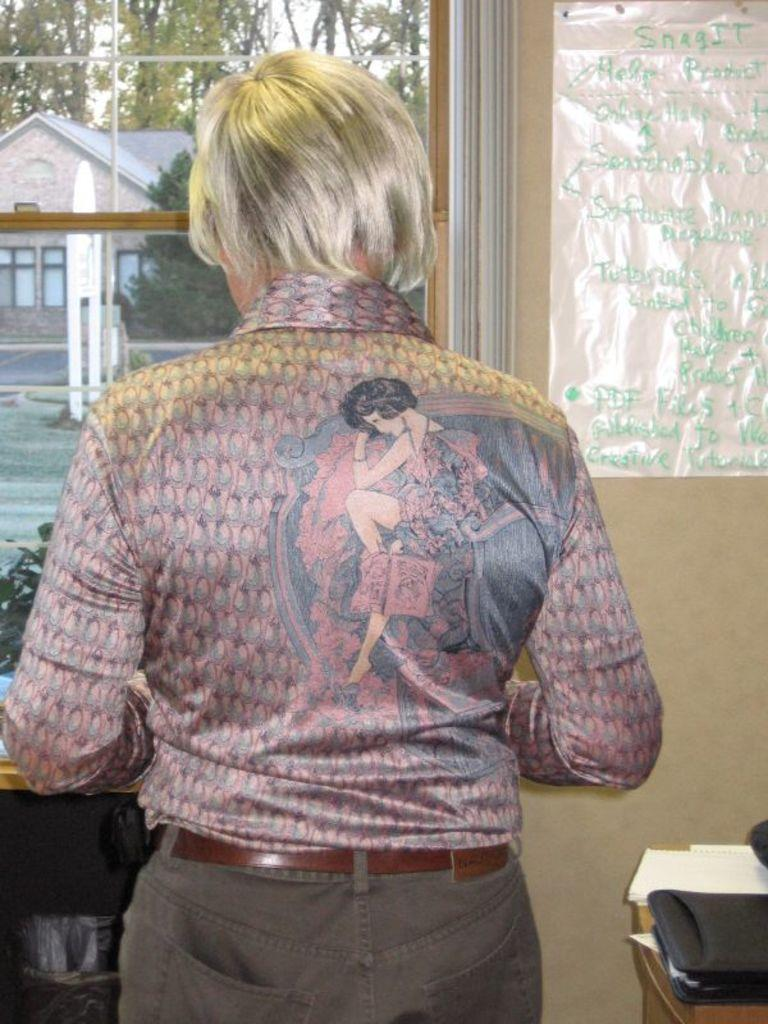What type of vegetation can be seen in the image? There are trees in the image. What type of structure is visible in the image? There is a house in the image. Who or what is standing in the image? There is a woman standing in the image. What type of beast can be seen playing with a toy in the image? There is no beast or toy present in the image; it features trees, a house, and a woman. In which country is the house located in the image? The country where the house is located is not mentioned in the image or the provided facts. 